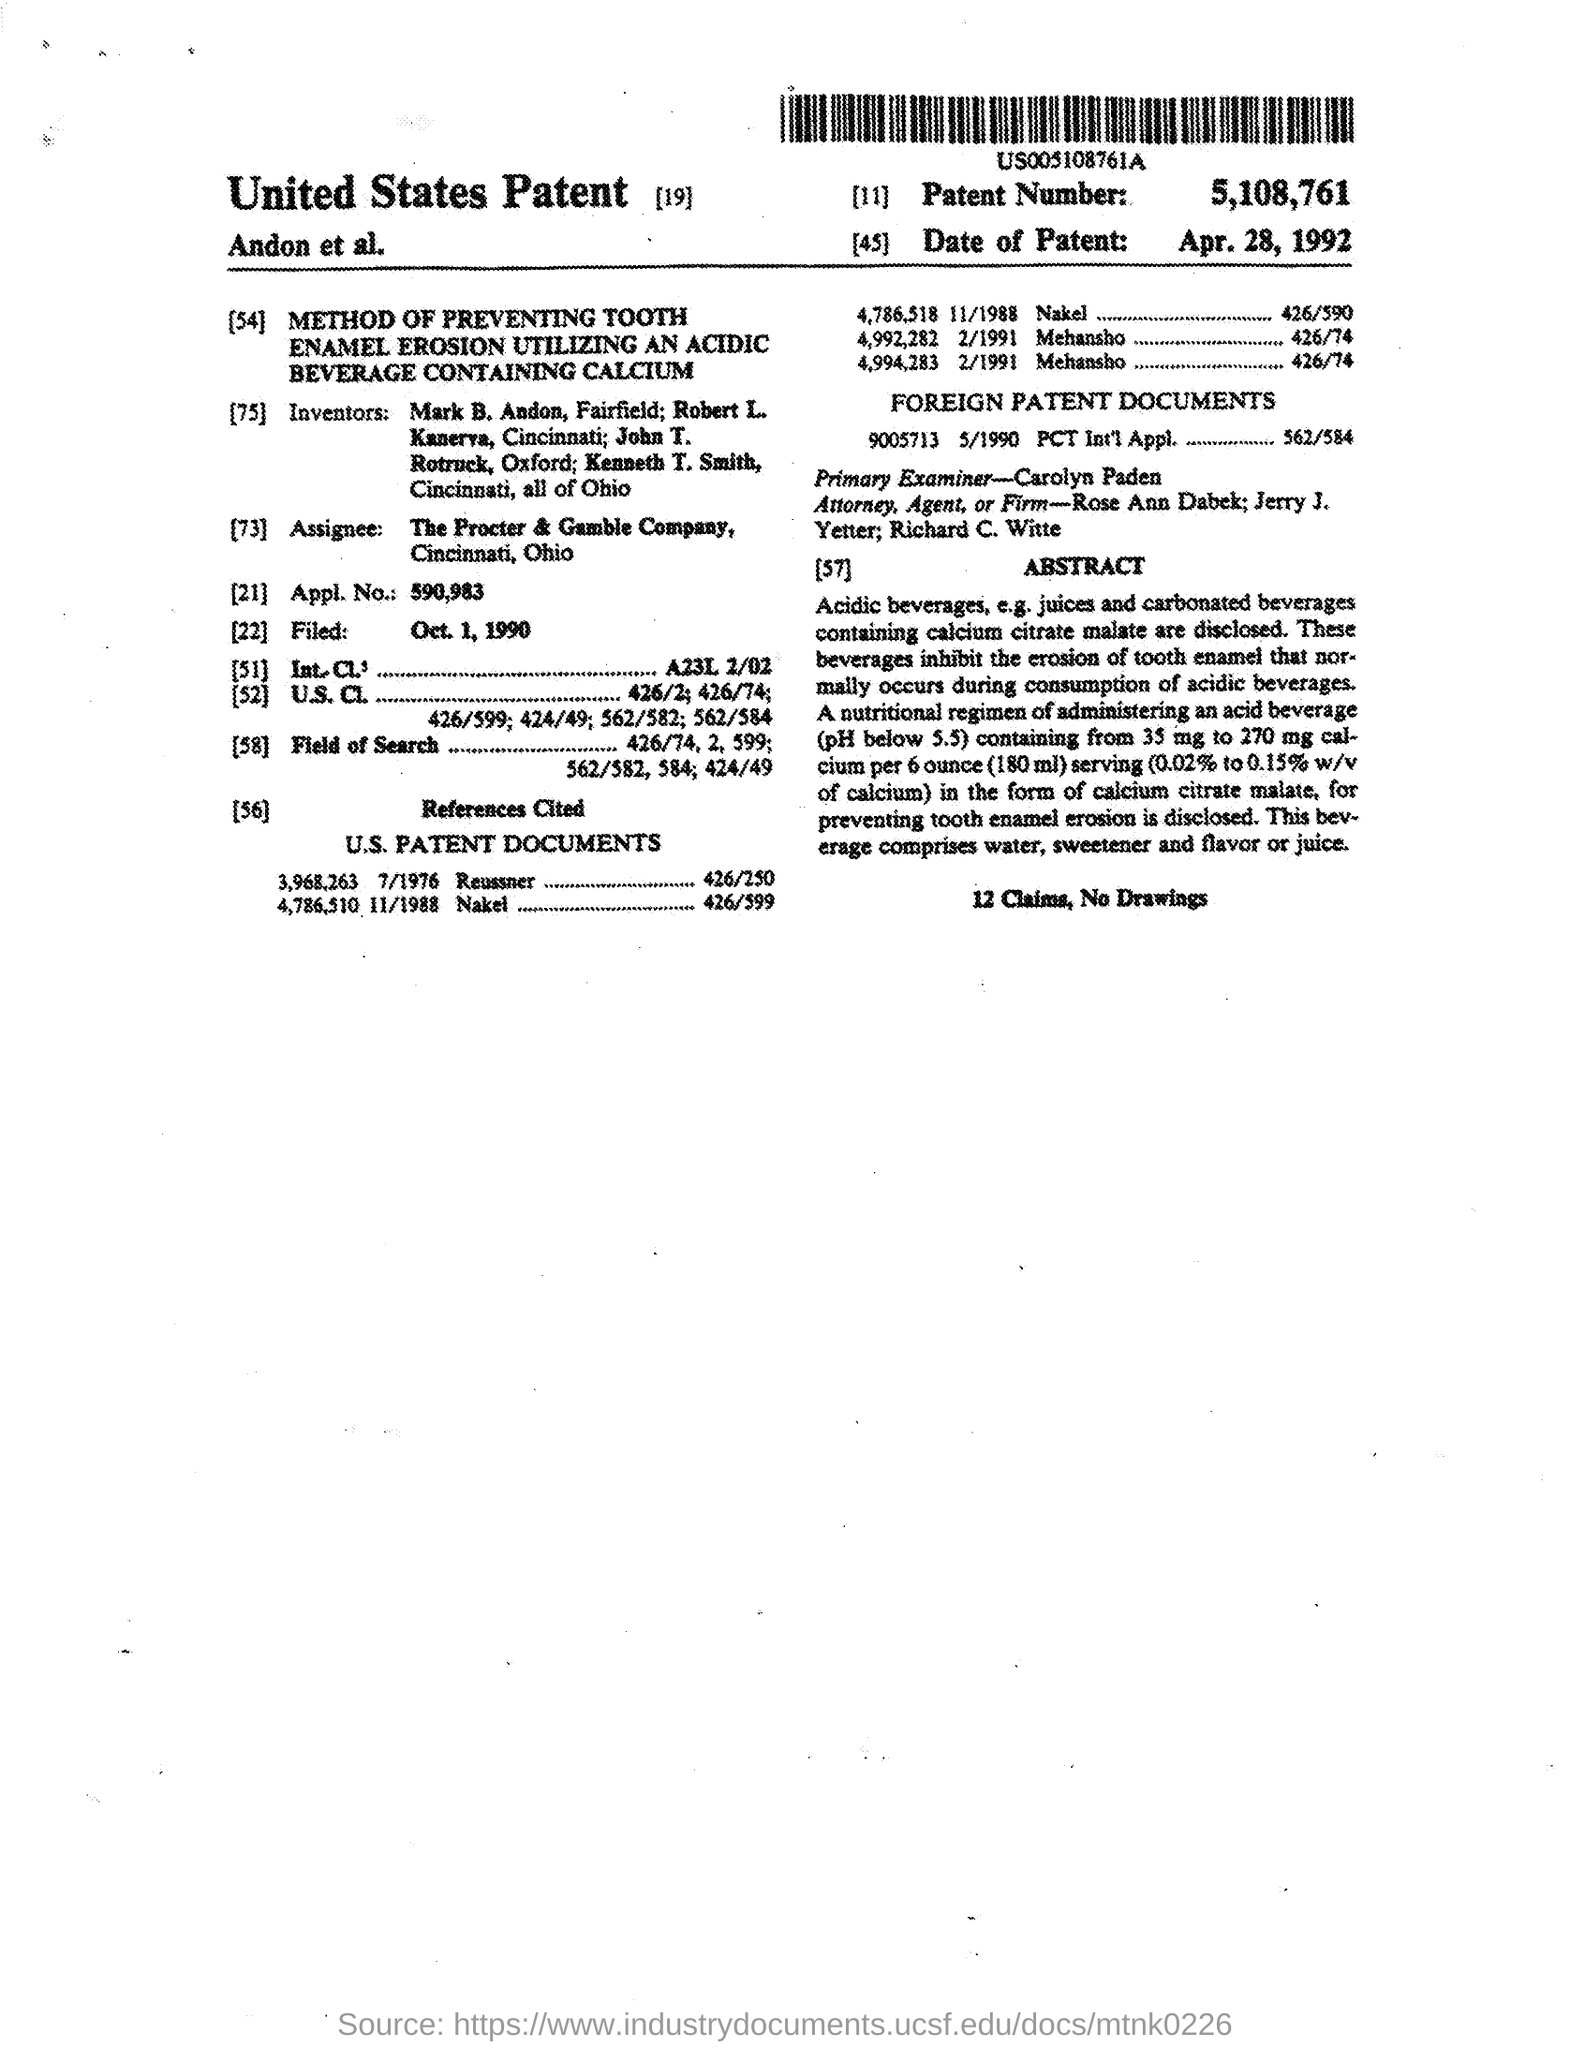What is the patent number mentioned in the given form ?
Offer a terse response. 5,108,761. What is the date of patent mentioned in the given form ?
Give a very brief answer. Apr. 28, 1992. What is the name of primary examiner mentioned in the given form ?
Ensure brevity in your answer.  Carolyn paden. What is the appl. no. mentioned in the given form ?
Offer a very short reply. 590,983. What is the date of filed as mentioned in the given form ?
Give a very brief answer. Oct. 1, 1990. 